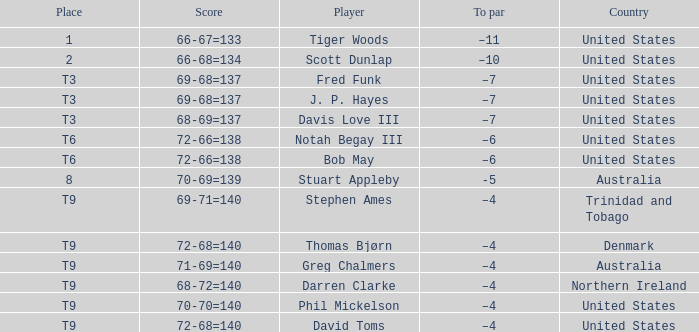What country is Darren Clarke from? Northern Ireland. 